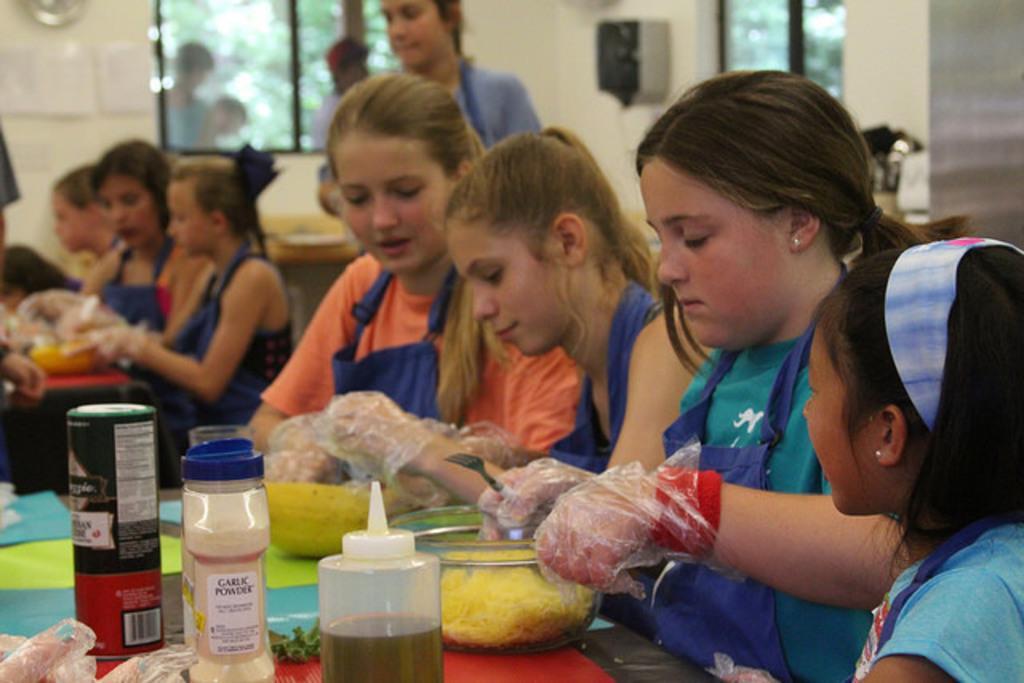Please provide a concise description of this image. In the image we can see there are girls who are sitting on the chair and in front of them there is a table on which there is a bowl there are noodles in it. The girls are wearing plastic covers in their hand. They are also wearing blue colour aprons and there are ketchup bottle and garlic powder bottles on the table. 